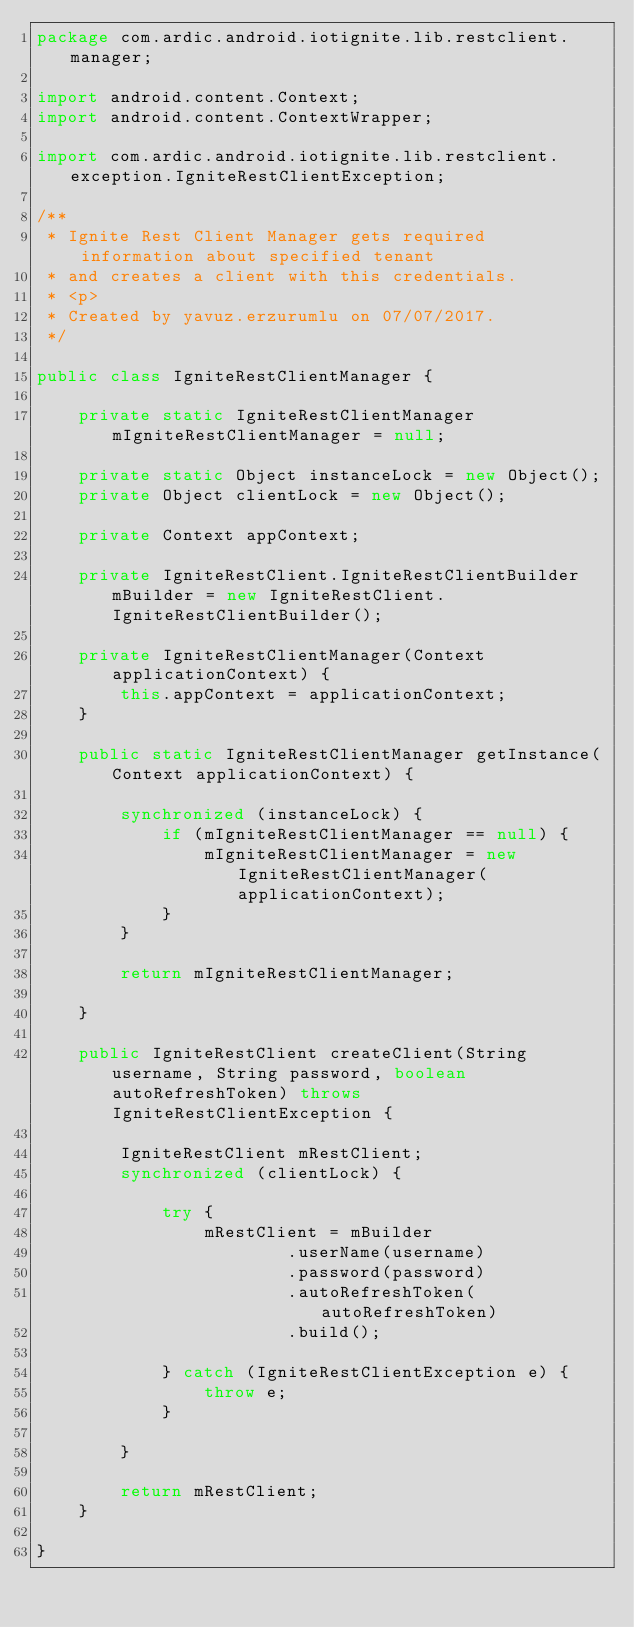Convert code to text. <code><loc_0><loc_0><loc_500><loc_500><_Java_>package com.ardic.android.iotignite.lib.restclient.manager;

import android.content.Context;
import android.content.ContextWrapper;

import com.ardic.android.iotignite.lib.restclient.exception.IgniteRestClientException;

/**
 * Ignite Rest Client Manager gets required information about specified tenant
 * and creates a client with this credentials.
 * <p>
 * Created by yavuz.erzurumlu on 07/07/2017.
 */

public class IgniteRestClientManager {

    private static IgniteRestClientManager mIgniteRestClientManager = null;

    private static Object instanceLock = new Object();
    private Object clientLock = new Object();

    private Context appContext;

    private IgniteRestClient.IgniteRestClientBuilder mBuilder = new IgniteRestClient.IgniteRestClientBuilder();

    private IgniteRestClientManager(Context applicationContext) {
        this.appContext = applicationContext;
    }

    public static IgniteRestClientManager getInstance(Context applicationContext) {

        synchronized (instanceLock) {
            if (mIgniteRestClientManager == null) {
                mIgniteRestClientManager = new IgniteRestClientManager(applicationContext);
            }
        }

        return mIgniteRestClientManager;

    }

    public IgniteRestClient createClient(String username, String password, boolean autoRefreshToken) throws IgniteRestClientException {

        IgniteRestClient mRestClient;
        synchronized (clientLock) {

            try {
                mRestClient = mBuilder
                        .userName(username)
                        .password(password)
                        .autoRefreshToken(autoRefreshToken)
                        .build();

            } catch (IgniteRestClientException e) {
                throw e;
            }

        }

        return mRestClient;
    }

}
</code> 